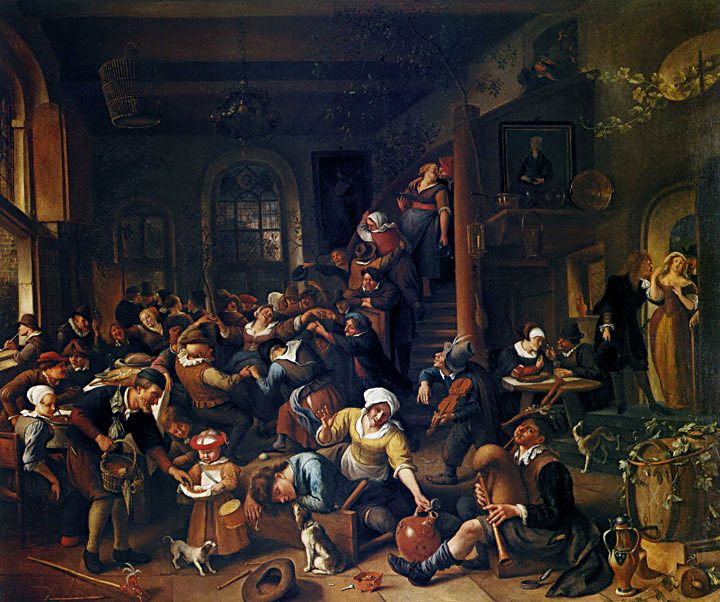What can we infer about the social class of the people depicted in the painting? The individuals in the painting appear to be from various social strata, which is evident from their clothing and activities. While some wear finer fabrics that suggest a higher social standing, others are in simpler, more worn attire indicating lower social status. The mingling of these classes in one room could reflect the nature of public taverns as communal spaces where different social classes could interact, albeit not necessarily as equals. Do social interactions like this have historical significance? Indeed, taverns in historical contexts often served as critical hubs for social and political discourse, transcending class boundaries. They were venues where news was exchanged, and sometimes political or economic agreements were struck informally. Such interactions are significant as they provide insight into the social dynamics of the period, often overlooked in more formal historical records. 